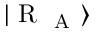<formula> <loc_0><loc_0><loc_500><loc_500>| R _ { A } \rangle</formula> 